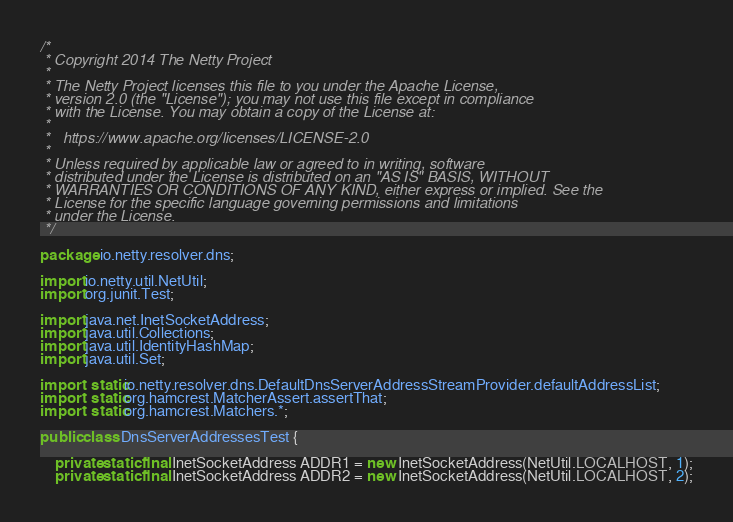Convert code to text. <code><loc_0><loc_0><loc_500><loc_500><_Java_>/*
 * Copyright 2014 The Netty Project
 *
 * The Netty Project licenses this file to you under the Apache License,
 * version 2.0 (the "License"); you may not use this file except in compliance
 * with the License. You may obtain a copy of the License at:
 *
 *   https://www.apache.org/licenses/LICENSE-2.0
 *
 * Unless required by applicable law or agreed to in writing, software
 * distributed under the License is distributed on an "AS IS" BASIS, WITHOUT
 * WARRANTIES OR CONDITIONS OF ANY KIND, either express or implied. See the
 * License for the specific language governing permissions and limitations
 * under the License.
 */

package io.netty.resolver.dns;

import io.netty.util.NetUtil;
import org.junit.Test;

import java.net.InetSocketAddress;
import java.util.Collections;
import java.util.IdentityHashMap;
import java.util.Set;

import static io.netty.resolver.dns.DefaultDnsServerAddressStreamProvider.defaultAddressList;
import static org.hamcrest.MatcherAssert.assertThat;
import static org.hamcrest.Matchers.*;

public class DnsServerAddressesTest {

    private static final InetSocketAddress ADDR1 = new InetSocketAddress(NetUtil.LOCALHOST, 1);
    private static final InetSocketAddress ADDR2 = new InetSocketAddress(NetUtil.LOCALHOST, 2);</code> 